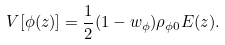Convert formula to latex. <formula><loc_0><loc_0><loc_500><loc_500>V [ \phi ( z ) ] = \frac { 1 } { 2 } ( 1 - w _ { \phi } ) \rho _ { \phi 0 } E ( z ) .</formula> 